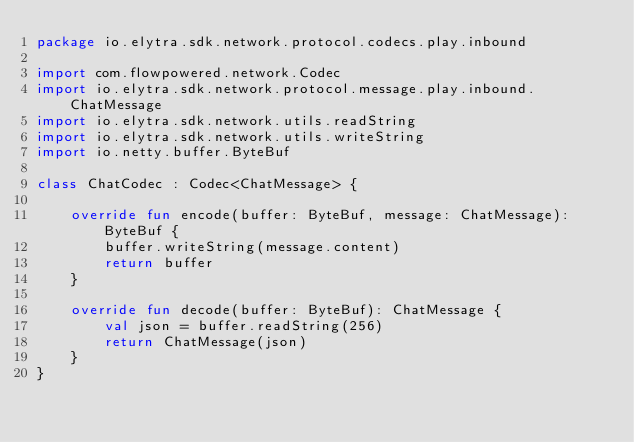<code> <loc_0><loc_0><loc_500><loc_500><_Kotlin_>package io.elytra.sdk.network.protocol.codecs.play.inbound

import com.flowpowered.network.Codec
import io.elytra.sdk.network.protocol.message.play.inbound.ChatMessage
import io.elytra.sdk.network.utils.readString
import io.elytra.sdk.network.utils.writeString
import io.netty.buffer.ByteBuf

class ChatCodec : Codec<ChatMessage> {

    override fun encode(buffer: ByteBuf, message: ChatMessage): ByteBuf {
        buffer.writeString(message.content)
        return buffer
    }

    override fun decode(buffer: ByteBuf): ChatMessage {
        val json = buffer.readString(256)
        return ChatMessage(json)
    }
}
</code> 